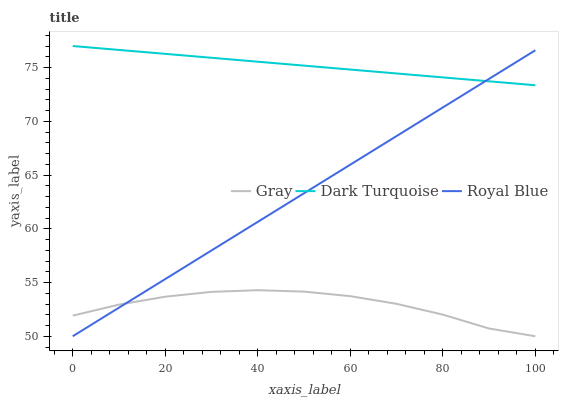Does Gray have the minimum area under the curve?
Answer yes or no. Yes. Does Dark Turquoise have the maximum area under the curve?
Answer yes or no. Yes. Does Royal Blue have the minimum area under the curve?
Answer yes or no. No. Does Royal Blue have the maximum area under the curve?
Answer yes or no. No. Is Dark Turquoise the smoothest?
Answer yes or no. Yes. Is Gray the roughest?
Answer yes or no. Yes. Is Royal Blue the smoothest?
Answer yes or no. No. Is Royal Blue the roughest?
Answer yes or no. No. Does Gray have the lowest value?
Answer yes or no. Yes. Does Dark Turquoise have the lowest value?
Answer yes or no. No. Does Dark Turquoise have the highest value?
Answer yes or no. Yes. Does Royal Blue have the highest value?
Answer yes or no. No. Is Gray less than Dark Turquoise?
Answer yes or no. Yes. Is Dark Turquoise greater than Gray?
Answer yes or no. Yes. Does Gray intersect Royal Blue?
Answer yes or no. Yes. Is Gray less than Royal Blue?
Answer yes or no. No. Is Gray greater than Royal Blue?
Answer yes or no. No. Does Gray intersect Dark Turquoise?
Answer yes or no. No. 